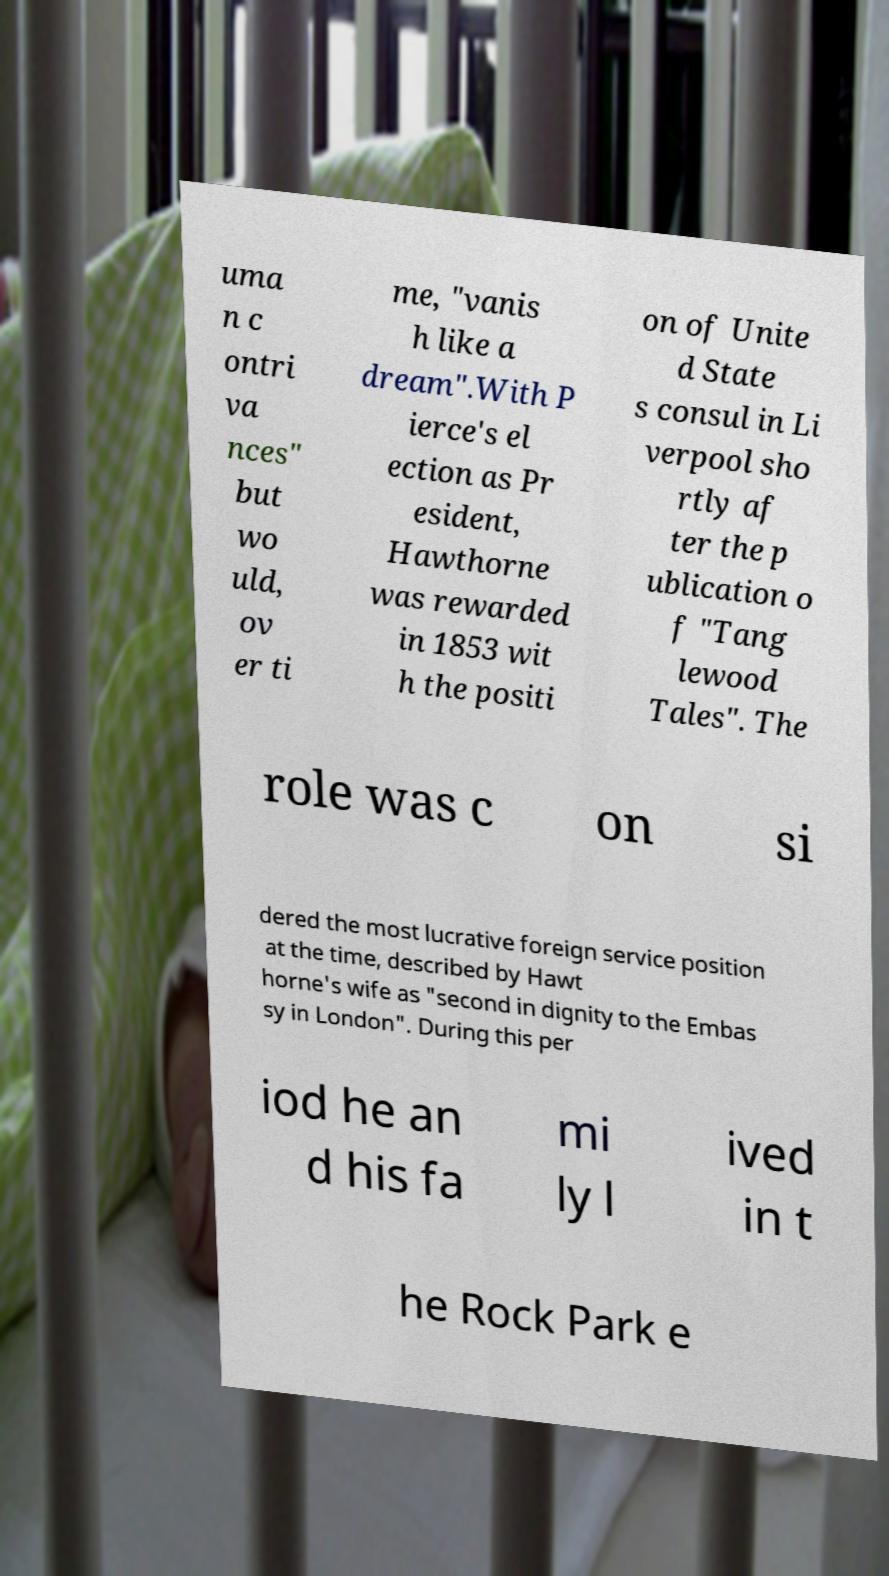Can you accurately transcribe the text from the provided image for me? uma n c ontri va nces" but wo uld, ov er ti me, "vanis h like a dream".With P ierce's el ection as Pr esident, Hawthorne was rewarded in 1853 wit h the positi on of Unite d State s consul in Li verpool sho rtly af ter the p ublication o f "Tang lewood Tales". The role was c on si dered the most lucrative foreign service position at the time, described by Hawt horne's wife as "second in dignity to the Embas sy in London". During this per iod he an d his fa mi ly l ived in t he Rock Park e 